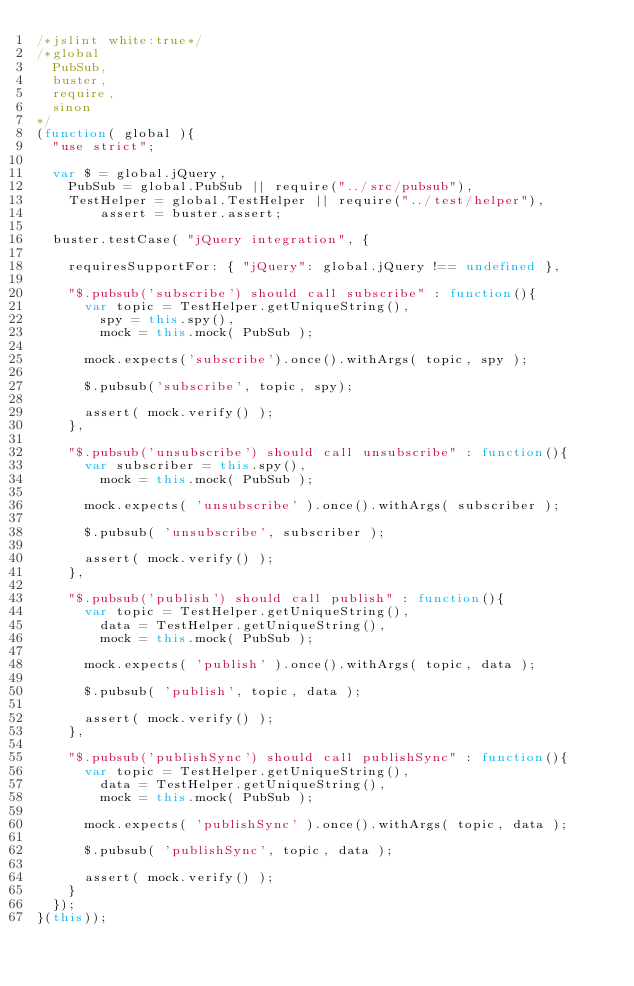<code> <loc_0><loc_0><loc_500><loc_500><_JavaScript_>/*jslint white:true*/
/*global
	PubSub,
	buster,
	require,
	sinon
*/
(function( global ){
	"use strict";
	
	var $ = global.jQuery,
		PubSub = global.PubSub || require("../src/pubsub"),
		TestHelper = global.TestHelper || require("../test/helper"),
        assert = buster.assert;

	buster.testCase( "jQuery integration", {

		requiresSupportFor: { "jQuery": global.jQuery !== undefined },

		"$.pubsub('subscribe') should call subscribe" : function(){
			var topic = TestHelper.getUniqueString(),
				spy = this.spy(),
				mock = this.mock( PubSub );

			mock.expects('subscribe').once().withArgs( topic, spy );

			$.pubsub('subscribe', topic, spy);

			assert( mock.verify() );
		},

		"$.pubsub('unsubscribe') should call unsubscribe" : function(){
			var subscriber = this.spy(),
				mock = this.mock( PubSub );

			mock.expects( 'unsubscribe' ).once().withArgs( subscriber );
			
			$.pubsub( 'unsubscribe', subscriber );

			assert( mock.verify() );
		},

		"$.pubsub('publish') should call publish" : function(){
			var topic = TestHelper.getUniqueString(),
				data = TestHelper.getUniqueString(),
				mock = this.mock( PubSub );

			mock.expects( 'publish' ).once().withArgs( topic, data );

			$.pubsub( 'publish', topic, data );

			assert( mock.verify() );	
		},

		"$.pubsub('publishSync') should call publishSync" : function(){
			var topic = TestHelper.getUniqueString(),
				data = TestHelper.getUniqueString(),
				mock = this.mock( PubSub );

			mock.expects( 'publishSync' ).once().withArgs( topic, data );

			$.pubsub( 'publishSync', topic, data );

			assert( mock.verify() );	
		}
	});
}(this));
</code> 